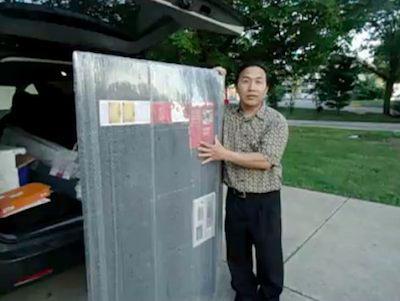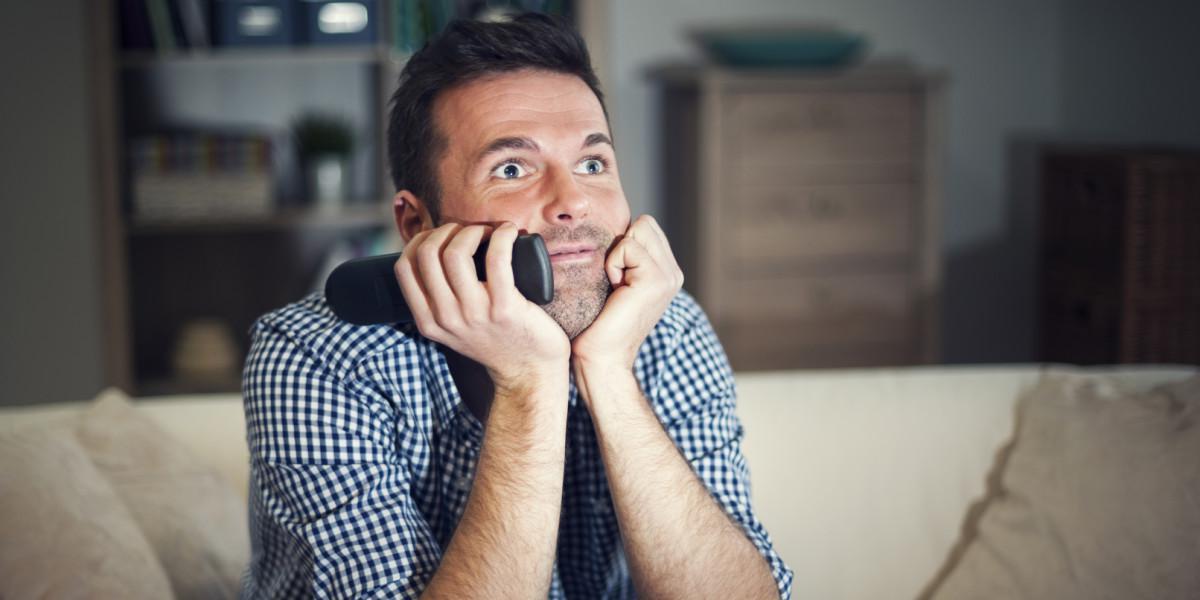The first image is the image on the left, the second image is the image on the right. For the images shown, is this caption "At least one of the images shows a man with his arm around a woman's shoulder." true? Answer yes or no. No. The first image is the image on the left, the second image is the image on the right. Analyze the images presented: Is the assertion "In one image, a man and woman are standing together looking at a display television, the man's arm stretched out pointing at the screen." valid? Answer yes or no. No. 